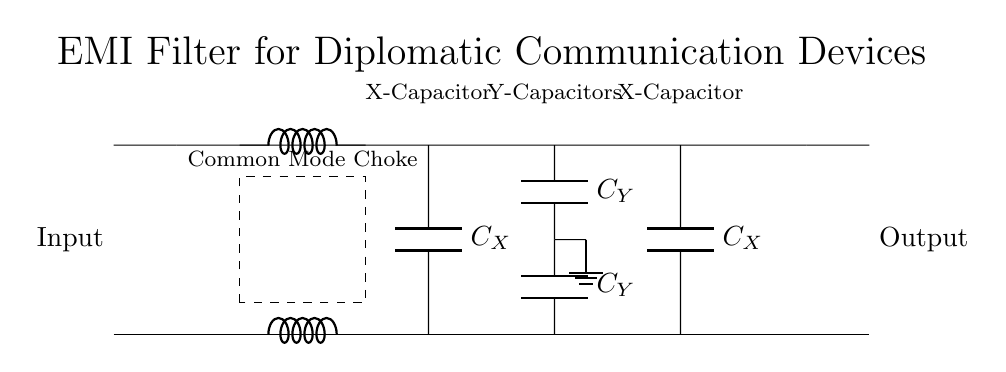What is the purpose of the common mode choke? The common mode choke is designed to filter out common mode noise from the input signals. It works by allowing differential signals to pass while attenuating common mode interference, which is crucial for maintaining signal integrity in diplomatic communication devices.
Answer: Filter out common mode noise How many capacitors are present in this circuit? The circuit diagram shows a total of four capacitors: two X-capacitors and two Y-capacitors. X-capacitors are connected to the input and output, while Y-capacitors are positioned in the center of the circuit.
Answer: Four capacitors What type of capacitors are used in the circuit? The circuit utilizes both X-capacitors and Y-capacitors. X-capacitors are typically used for line-to-line filtering, while Y-capacitors provide insulation between the line and ground to prevent electrical shock.
Answer: X and Y capacitors What is the configuration of the output connections? The output connections mirror the input connections, indicating a parallel configuration. This setup helps maintain the original signal characteristics while filtering out EMC issues.
Answer: Parallel configuration What is the primary benefit of incorporating EMI filters in diplomatic communication devices? The primary benefit is to reduce electromagnetic interference, ensuring clear and reliable communication. This is especially important in sensitive diplomatic contexts where information security is paramount.
Answer: Reduces electromagnetic interference What is the relationship between the common mode choke and EMI filtering? The common mode choke plays a critical role in EMI filtering by suppressing high-frequency noise that can affect signal quality, thereby enhancing the overall performance of the filter circuit.
Answer: Enhances performance by suppressing noise 